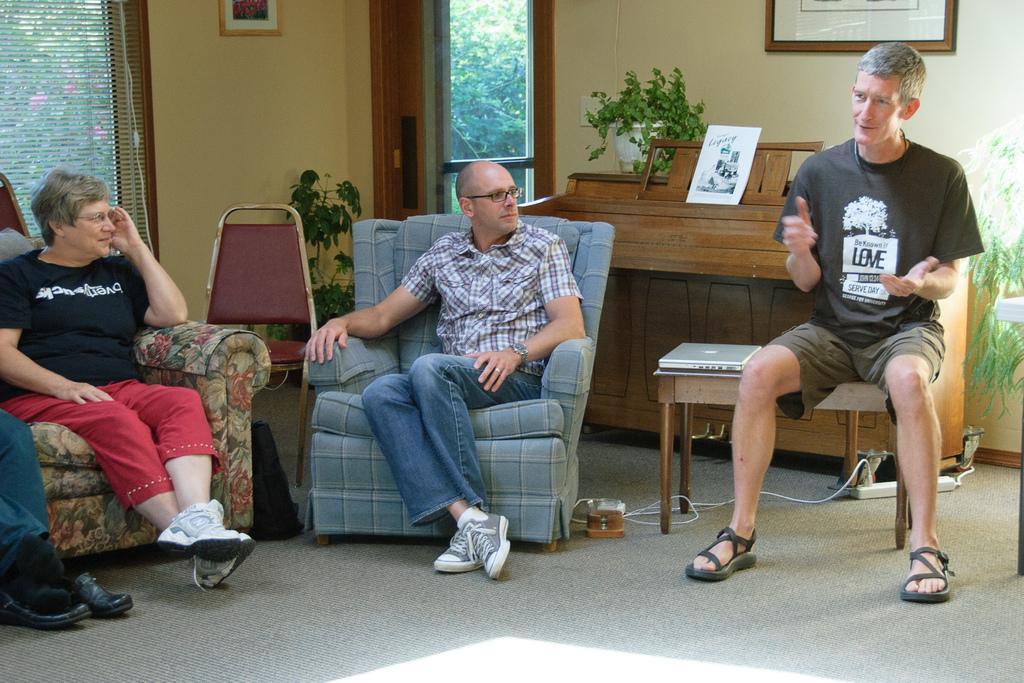Can you describe this image briefly? It is a picture inside a house there are two people sitting on the sofa and beside them a man is sitting on a table to his left there is a laptop behind him there is a wooden cupboard and some photo frame on that there is also a plant beside it in the background there is a door to the left to the wall there is some photo frame and beside it there is a window outside the window there are some trees. 